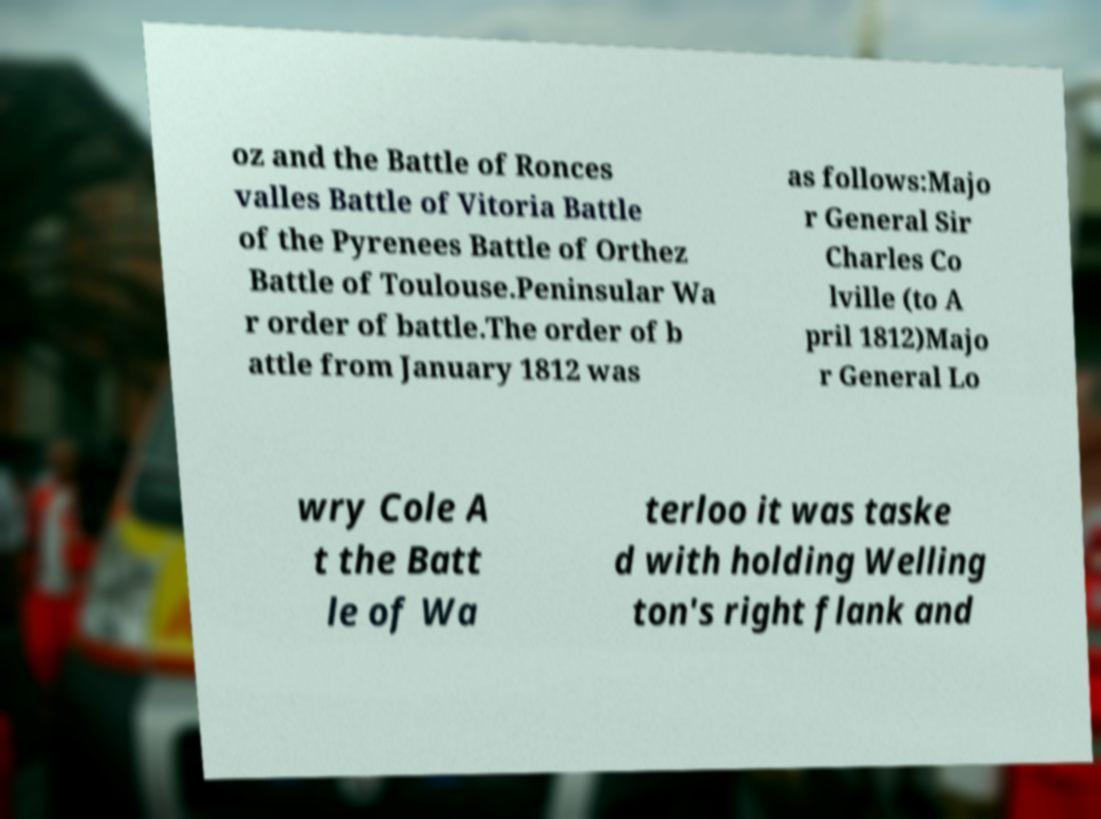Can you accurately transcribe the text from the provided image for me? oz and the Battle of Ronces valles Battle of Vitoria Battle of the Pyrenees Battle of Orthez Battle of Toulouse.Peninsular Wa r order of battle.The order of b attle from January 1812 was as follows:Majo r General Sir Charles Co lville (to A pril 1812)Majo r General Lo wry Cole A t the Batt le of Wa terloo it was taske d with holding Welling ton's right flank and 